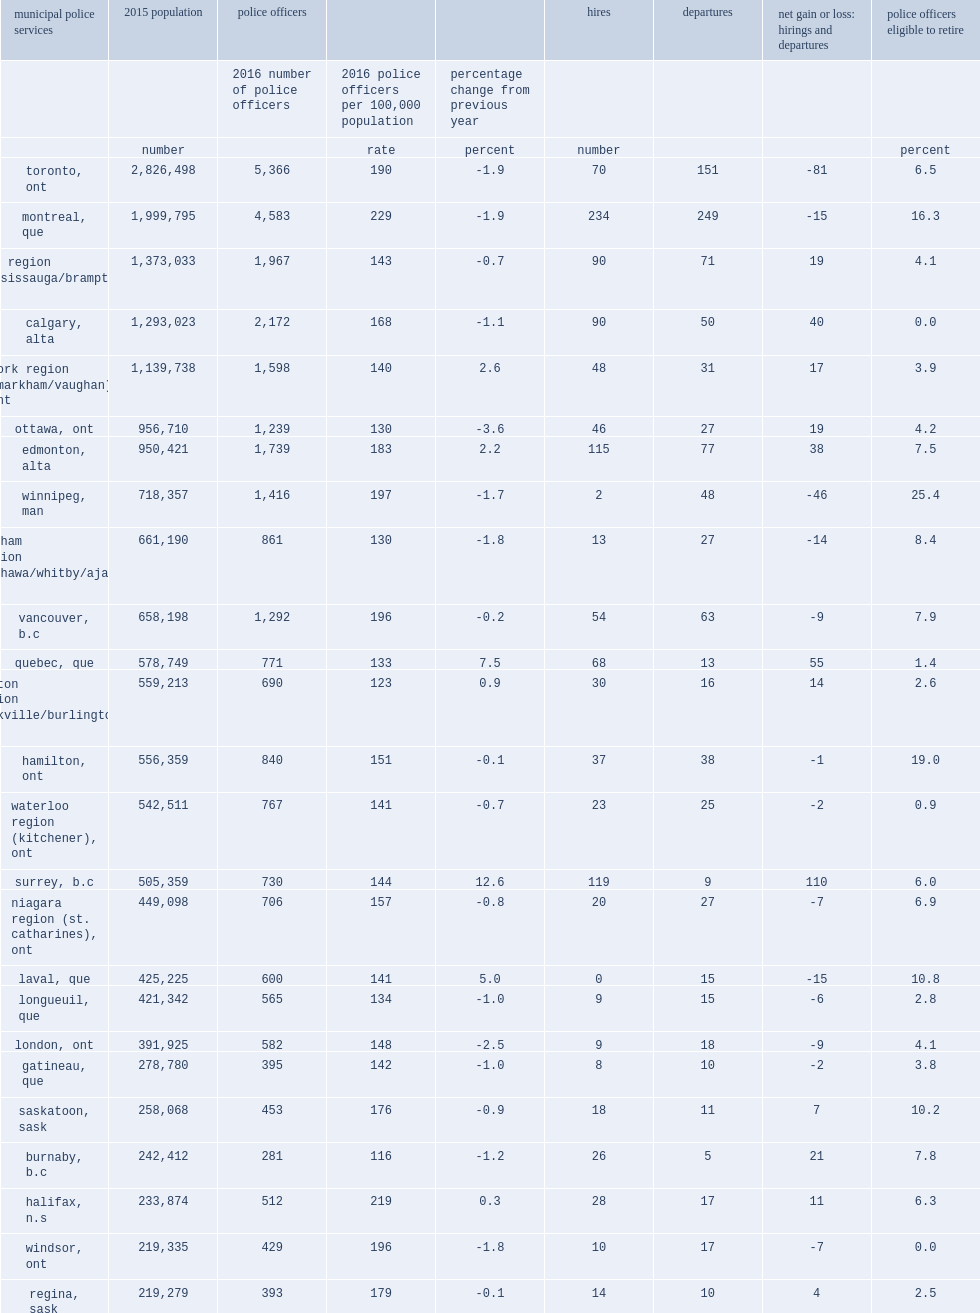Across the country in 2016,how many stand-alone municipal police services which served a population greater than 100,000? 50. Of these services, how many municipal police services saw an increase in their rate of police strength from 2015 to 2016? 17. Of these services, how many municipal police services saw an decrease in their rate of police strength from 2015 to 2016? 24. Of these services, how many municipal police services reported no notable change of strength from 2015 to 2016? 9. How much percentage points does the municipalities coquitlam, british columbia in police strength? 14.8. How much percentage points does the municipalities surrey, british columbia increases in police strength? 12.6. How much percentage points does the municipalities terrebonne, quebec in police strength? 9.2. Among the 50 municipal services, which city reported the largest decrease in rate of strength? Delta, b.c. What is the percentage of the municipality of delta, located in british columbia, reported declining? 12.5. How many police officers per 100,000 population has in victoria, british columbia? 236.0. How many police officers per 100,000 population has in montreal, quebec? 229.0. How many police officers per 100,000 population has in halifax, nova scotia? 219.0. How many police officers per 100,000 population has in british columbia's municipality of richmond? 97.0. How many police officers per 100,000 population has in richelieu saint-laurent,quebec? 105.0. How many police officers per 100,000 population has in levis,quebec? 106.0. 